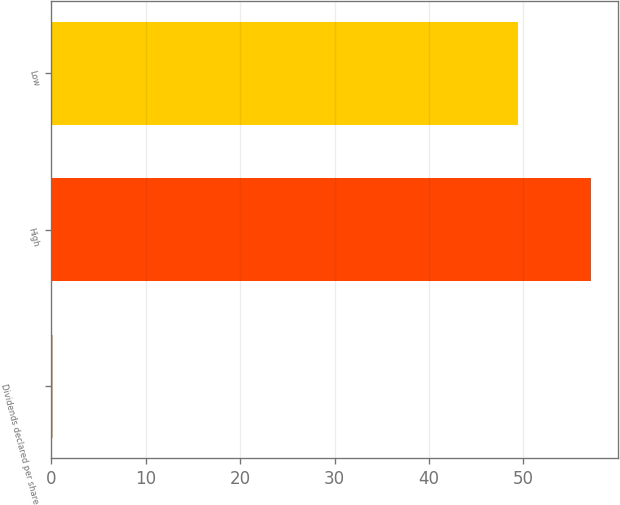<chart> <loc_0><loc_0><loc_500><loc_500><bar_chart><fcel>Dividends declared per share<fcel>High<fcel>Low<nl><fcel>0.21<fcel>57.14<fcel>49.43<nl></chart> 